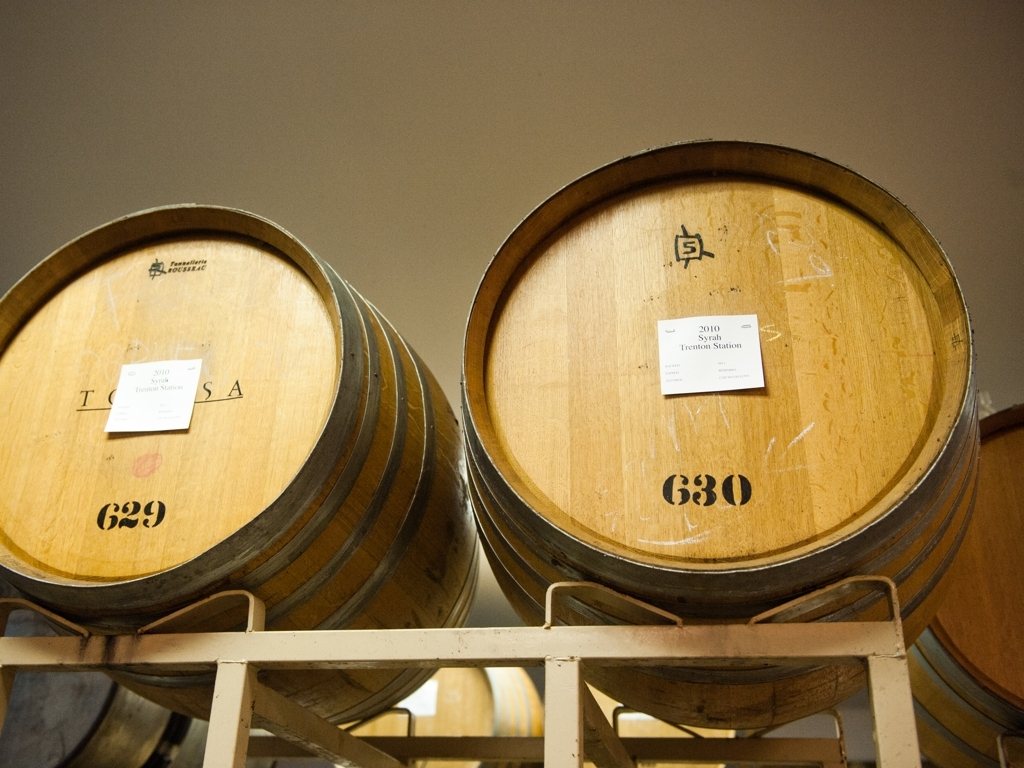Is there any apparent distortion in this photo?
A. Yes, there is subtle distortion.
B. Yes, there is noticeable distortion.
C. No, there is no apparent distortion.
D. Yes, there is severe distortion.
Answer with the option's letter from the given choices directly.
 C. 